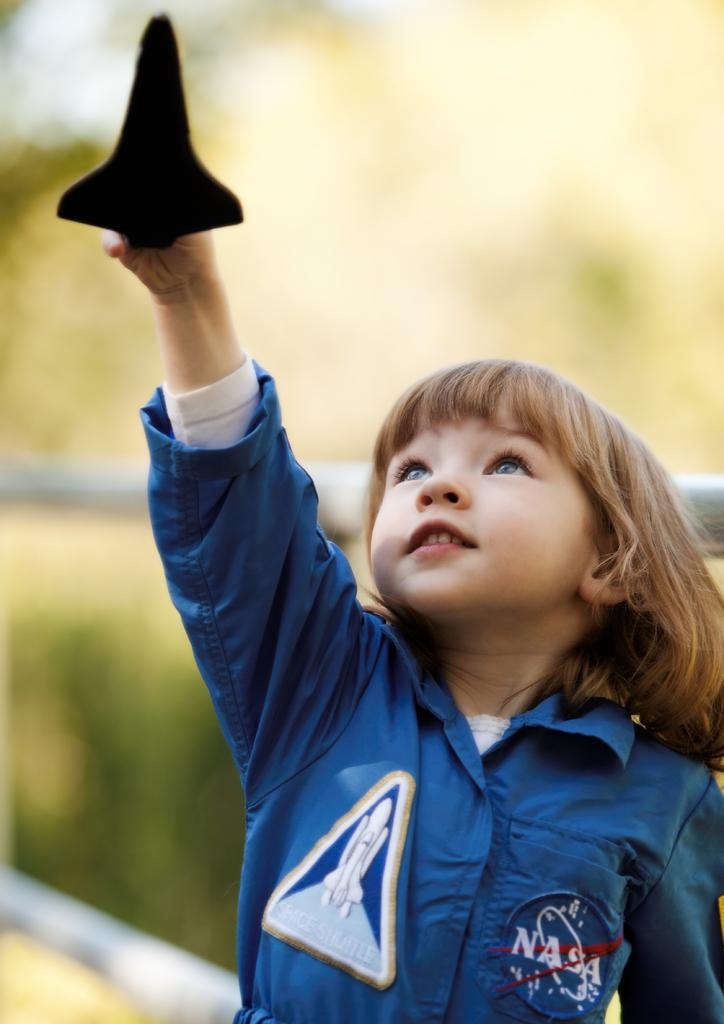Provide a one-sentence caption for the provided image. A small child wearing a blue NASA jump suit points a model of a space shuttle towards the sky. 